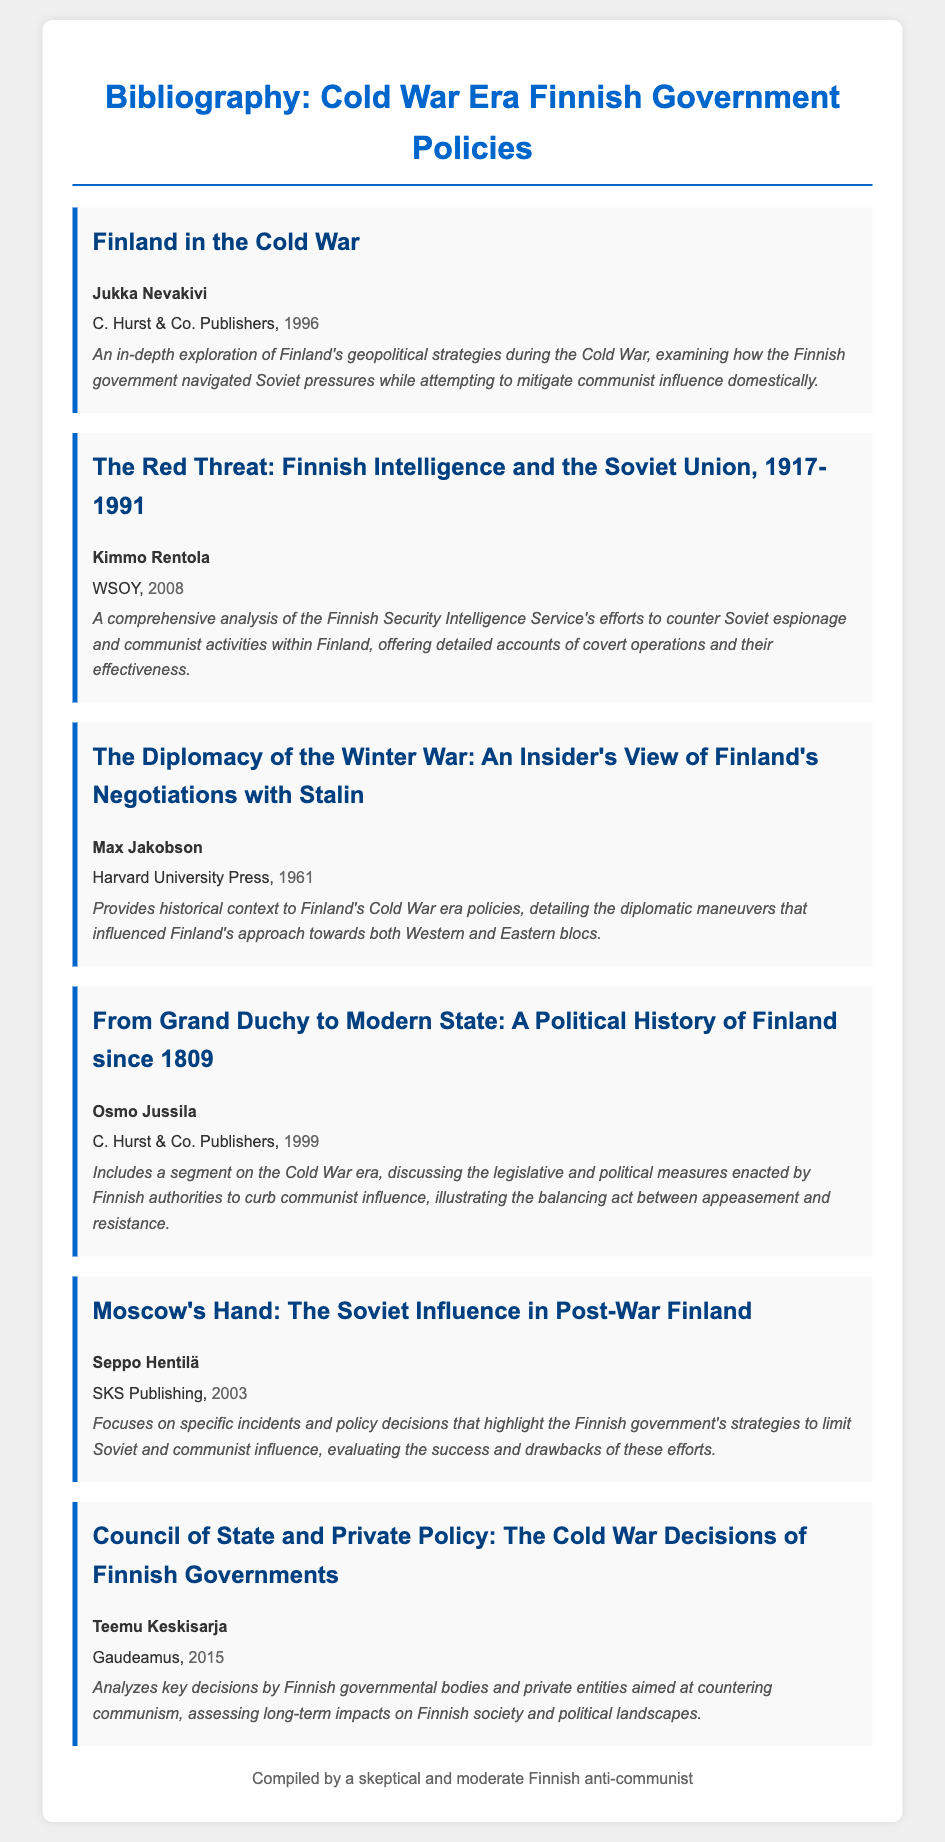What is the title of the first item? The title is the first piece of information listed under each bibliography item, which for the first item is "Finland in the Cold War."
Answer: Finland in the Cold War Who is the author of "The Red Threat: Finnish Intelligence and the Soviet Union, 1917-1991"? The author is mentioned in bold below the title of the item, which for this item is Kimmo Rentola.
Answer: Kimmo Rentola In what year was "The Diplomacy of the Winter War" published? The year is specified after the publisher's information for each item, and for this item, it is 1961.
Answer: 1961 What is the main focus of Seppo Hentilä's book? The description provides insight into the book's main themes, stating that it focuses on specific incidents and policy decisions regarding Soviet influence.
Answer: Soviet influence Which publisher released "From Grand Duchy to Modern State"? The publisher is mentioned directly after the author’s name, and for this work, it is C. Hurst & Co. Publishers.
Answer: C. Hurst & Co. Publishers How many bibliography items were written by Jukka Nevakivi? To answer this, we count the number of times the author's name appears in the document, and it appears only once for one title.
Answer: 1 What type of analysis does Teemu Keskisarja's book provide? The description indicates that it analyzes key decisions by Finnish governmental bodies and private entities regarding communism.
Answer: Analyzes key decisions What is the publication year of "Moscow's Hand"? The publication year is found next to the publisher's name, indicating that it was published in 2003.
Answer: 2003 